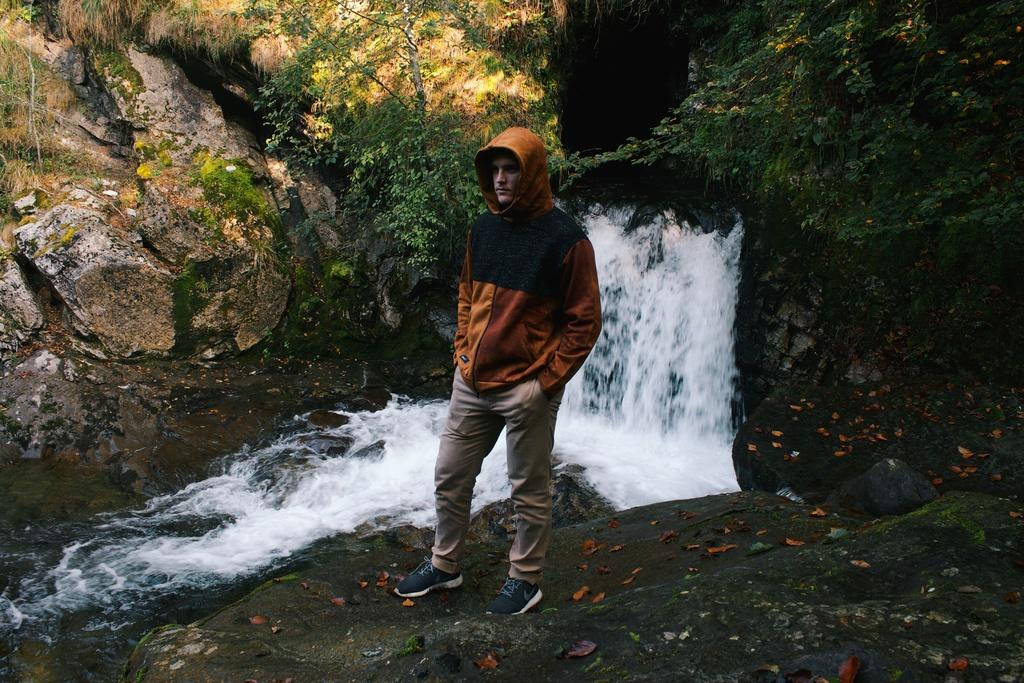What is the main subject of the image? There is a man standing in the image. Can you describe the man's attire? The man is wearing clothes and shoes. What natural feature can be seen in the image? There is a waterfall in the image. What other elements are present in the image? There are stones, algae, and plants in the image. What type of yak can be seen participating in the discussion in the image? There is no yak or discussion present in the image. How does the man wash his clothes in the image? There is no indication of the man washing his clothes in the image. 